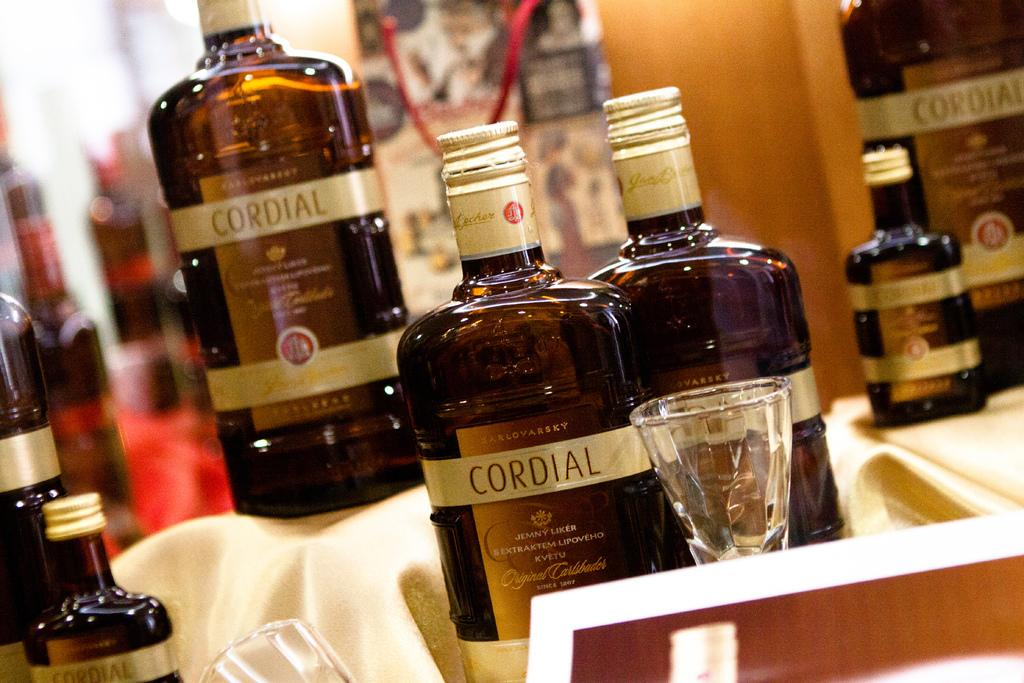<image>
Describe the image concisely. Here we have a display for several bottles of Cordial and some tasting glasses. 